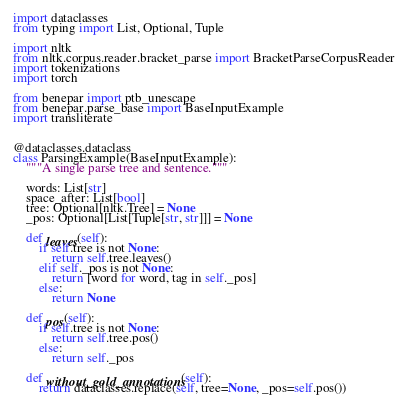Convert code to text. <code><loc_0><loc_0><loc_500><loc_500><_Python_>import dataclasses
from typing import List, Optional, Tuple

import nltk
from nltk.corpus.reader.bracket_parse import BracketParseCorpusReader
import tokenizations
import torch

from benepar import ptb_unescape
from benepar.parse_base import BaseInputExample
import transliterate


@dataclasses.dataclass
class ParsingExample(BaseInputExample):
    """A single parse tree and sentence."""

    words: List[str]
    space_after: List[bool]
    tree: Optional[nltk.Tree] = None
    _pos: Optional[List[Tuple[str, str]]] = None

    def leaves(self):
        if self.tree is not None:
            return self.tree.leaves()
        elif self._pos is not None:
            return [word for word, tag in self._pos]
        else:
            return None

    def pos(self):
        if self.tree is not None:
            return self.tree.pos()
        else:
            return self._pos

    def without_gold_annotations(self):
        return dataclasses.replace(self, tree=None, _pos=self.pos())

</code> 